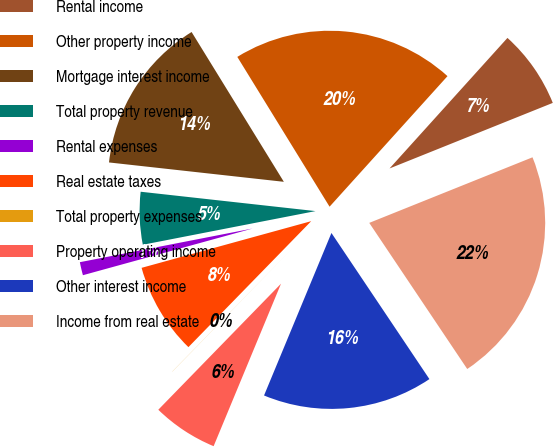<chart> <loc_0><loc_0><loc_500><loc_500><pie_chart><fcel>Rental income<fcel>Other property income<fcel>Mortgage interest income<fcel>Total property revenue<fcel>Rental expenses<fcel>Real estate taxes<fcel>Total property expenses<fcel>Property operating income<fcel>Other interest income<fcel>Income from real estate<nl><fcel>7.23%<fcel>20.48%<fcel>14.46%<fcel>4.82%<fcel>1.21%<fcel>8.43%<fcel>0.01%<fcel>6.03%<fcel>15.66%<fcel>21.68%<nl></chart> 